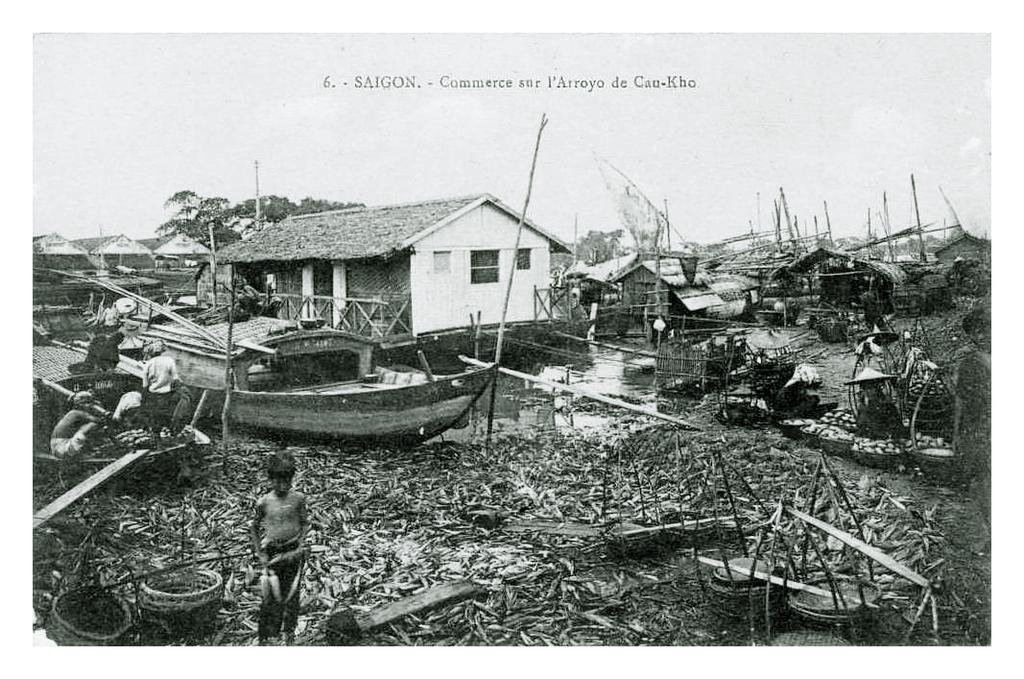Please provide a concise description of this image. In this image I can see the black and white picture in which I can see the water, a boat on the surface of the water, few persons standing, few poles, few trees, few houses and few other objects on the ground. In the background I can see the sky. 